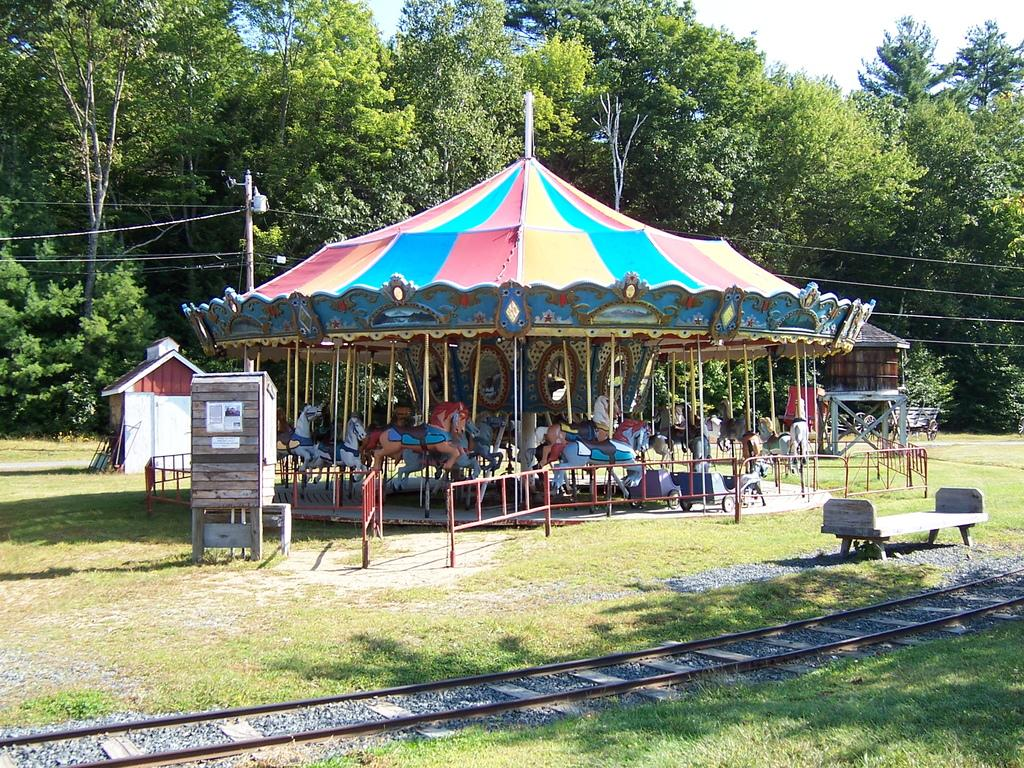What type of ride is in the image? There is a child carousel in the image. What can be seen in the background of the image? There are trees in the background of the image. What is located in front of the child carousel? There is a bench in front of the child carousel. What feature is present in front of the child carousel that might be used for the ride? There is a track in front of the child carousel. What type of box is being carried by the wind in the image? There is no box or wind present in the image. Can you describe the insects that are crawling on the child carousel in the image? There are no insects present on the child carousel in the image. 